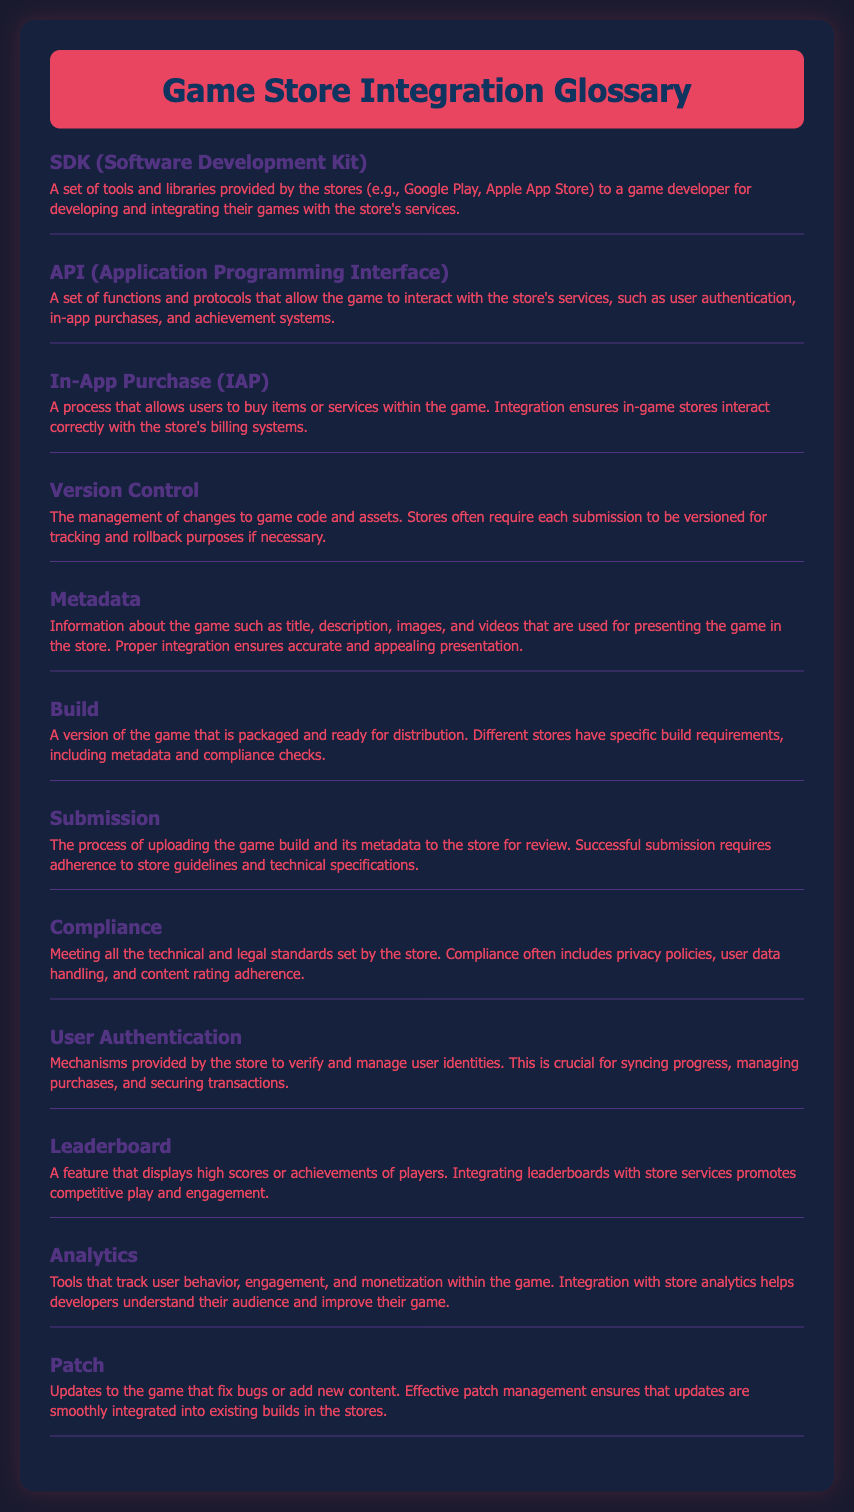what does SDK stand for? The term "SDK" is an abbreviation for "Software Development Kit."
Answer: Software Development Kit what is the purpose of an API? The API allows the game to interact with the store's services.
Answer: To interact with the store's services what does an In-App Purchase enable? In-App Purchases allow users to buy items or services within the game.
Answer: Buy items or services how is version control related to game submissions? It is the management of changes to game code and assets, which is required for versioning submissions.
Answer: Management of changes what information is included in metadata? Metadata includes title, description, images, and videos used for presenting the game.
Answer: Title, description, images, and videos how many glossary items are there? The document contains a total of 12 glossary items listed.
Answer: 12 what is the definition of Compliance? Compliance is meeting all technical and legal standards set by the store.
Answer: Meeting technical and legal standards why are leaderboards integrated with store services? Integrating leaderboards promotes competitive play and engagement among players.
Answer: To promote competitive play and engagement what does the term 'Patch' refer to? A patch refers to updates that fix bugs or add new content to the game.
Answer: Updates to fix bugs or add content 